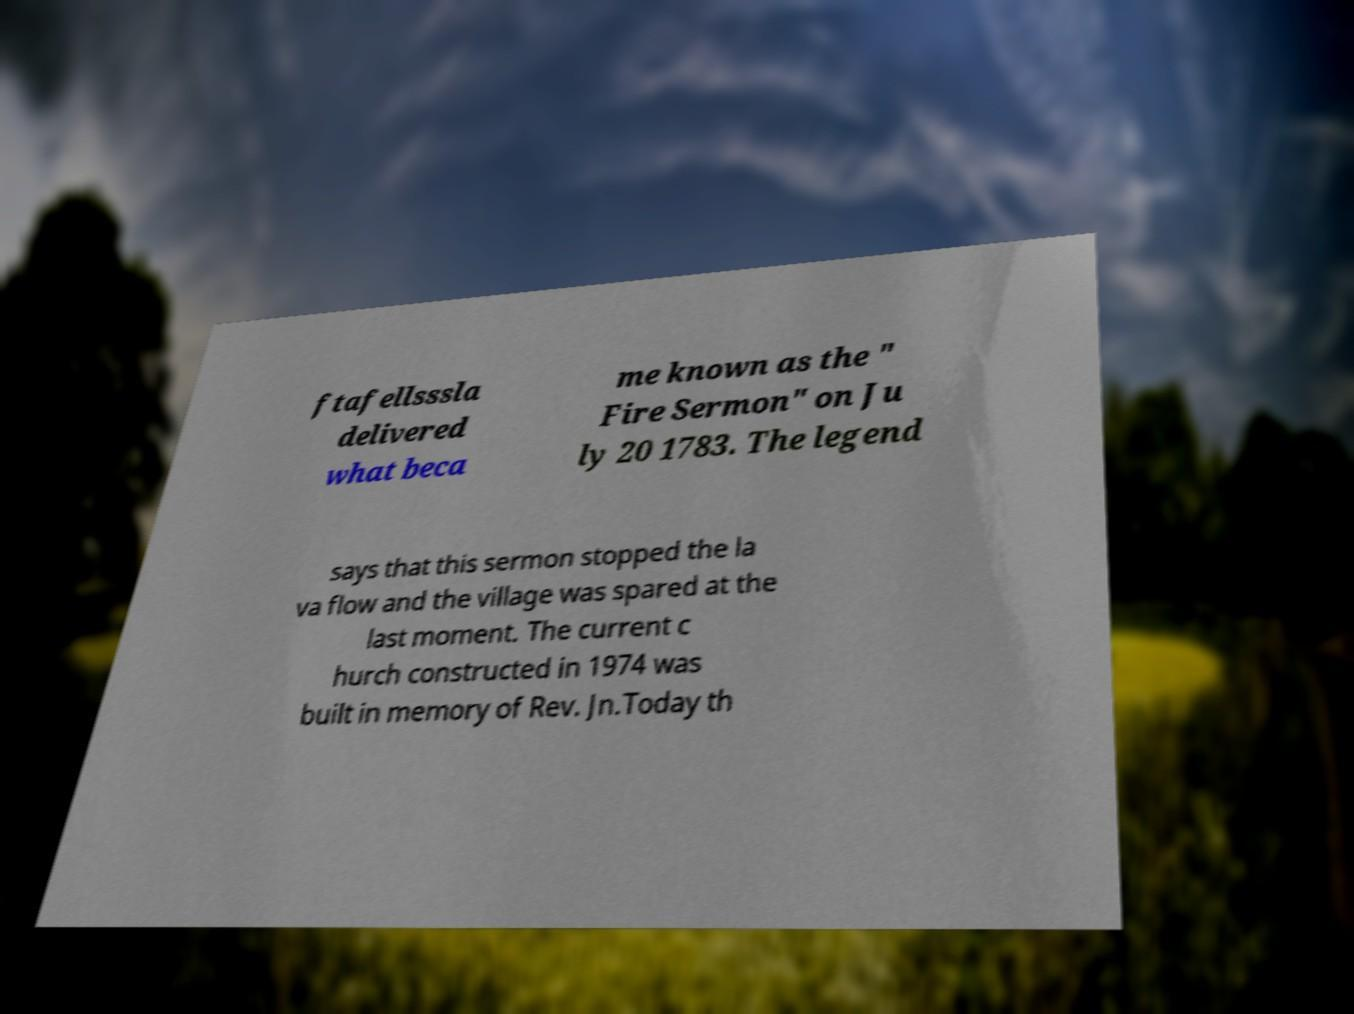I need the written content from this picture converted into text. Can you do that? ftafellsssla delivered what beca me known as the " Fire Sermon" on Ju ly 20 1783. The legend says that this sermon stopped the la va flow and the village was spared at the last moment. The current c hurch constructed in 1974 was built in memory of Rev. Jn.Today th 